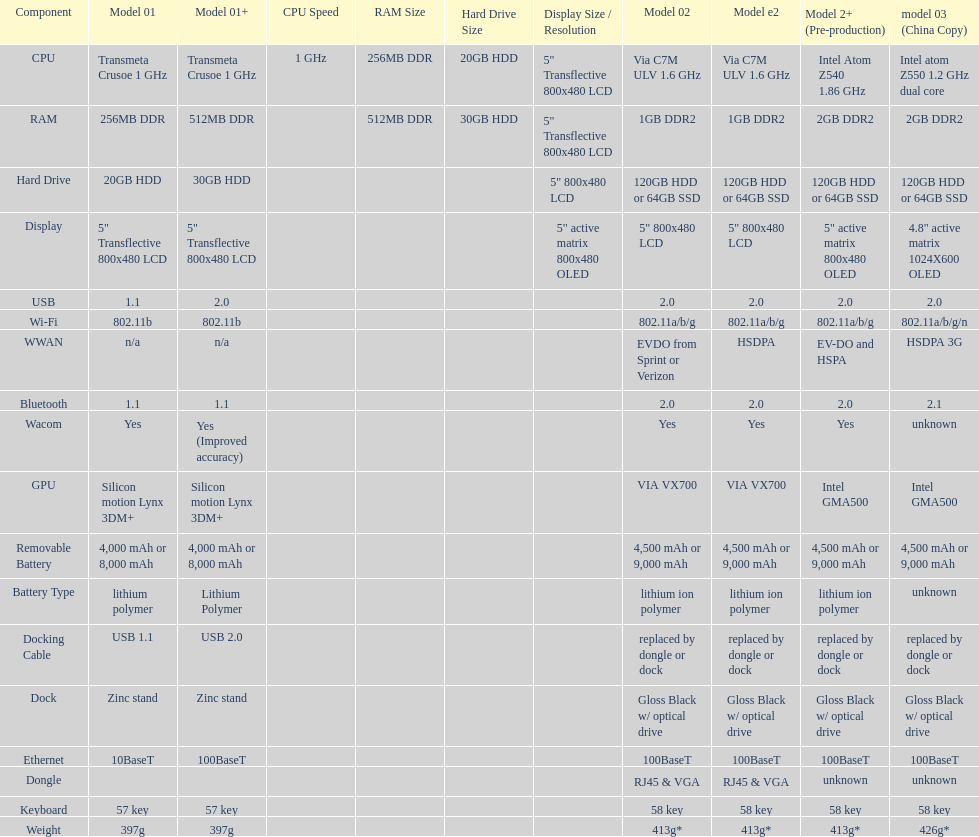What component comes after bluetooth? Wacom. 